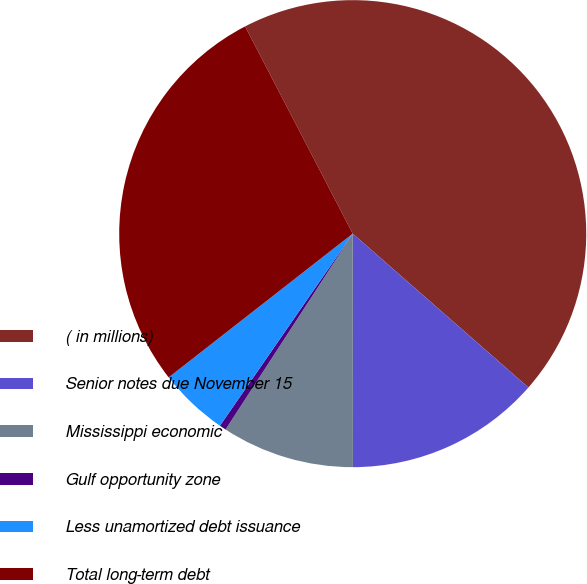<chart> <loc_0><loc_0><loc_500><loc_500><pie_chart><fcel>( in millions)<fcel>Senior notes due November 15<fcel>Mississippi economic<fcel>Gulf opportunity zone<fcel>Less unamortized debt issuance<fcel>Total long-term debt<nl><fcel>44.07%<fcel>13.54%<fcel>9.18%<fcel>0.46%<fcel>4.82%<fcel>27.93%<nl></chart> 